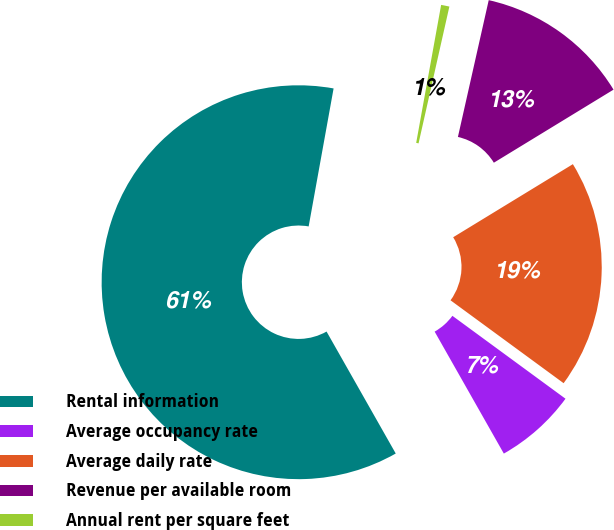Convert chart. <chart><loc_0><loc_0><loc_500><loc_500><pie_chart><fcel>Rental information<fcel>Average occupancy rate<fcel>Average daily rate<fcel>Revenue per available room<fcel>Annual rent per square feet<nl><fcel>61.06%<fcel>6.72%<fcel>18.79%<fcel>12.75%<fcel>0.68%<nl></chart> 